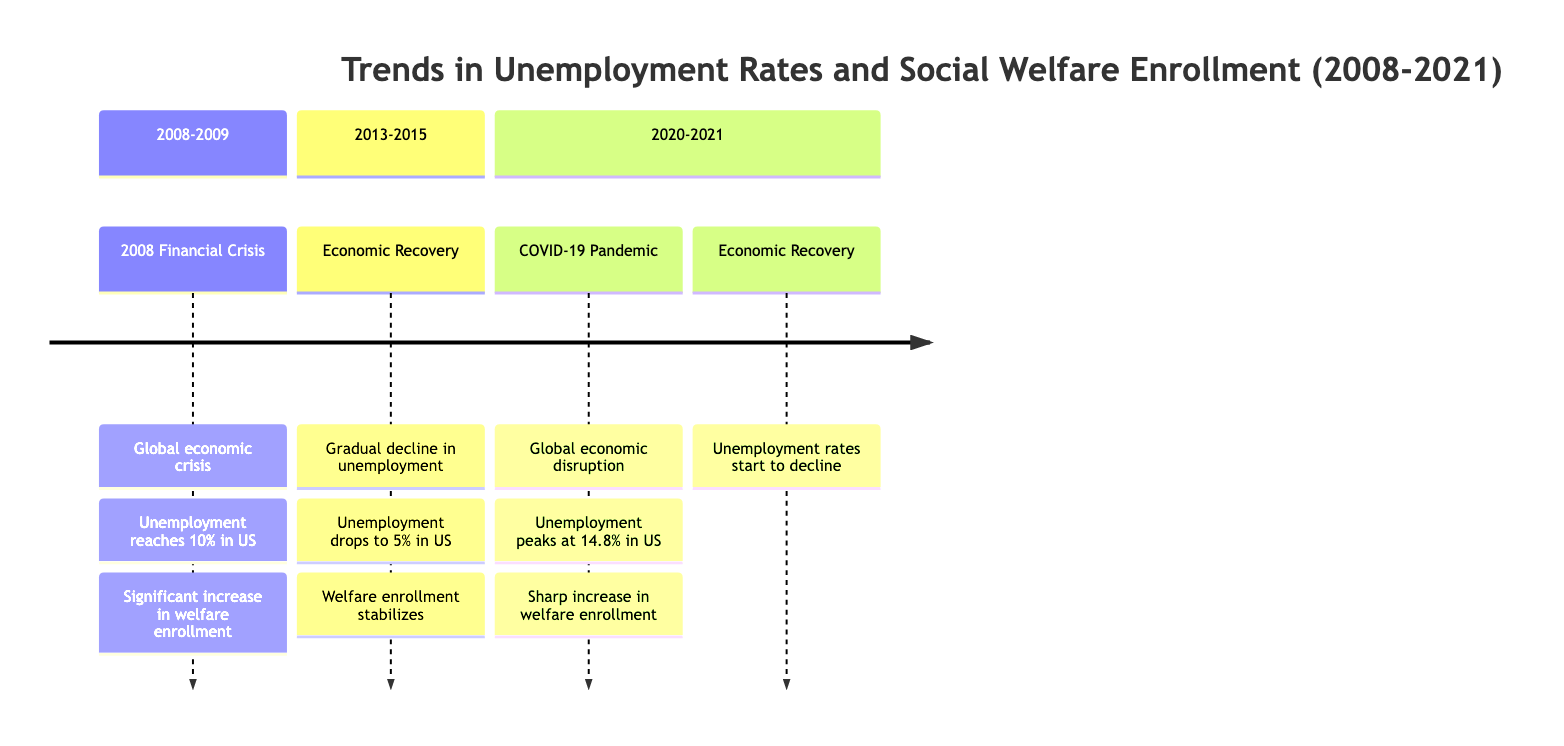What was the unemployment rate peak during the COVID-19 pandemic? The diagram notes that unemployment peaked at 14.8% during the COVID-19 pandemic, thus answering directly from the section labeled "2020-2021."
Answer: 14.8% What economic event corresponds to the spike in welfare enrollment in 2008? The diagram associates the 2008 Financial Crisis with a significant increase in welfare enrollment, linking these events within the same section.
Answer: 2008 Financial Crisis What was the unemployment rate in the U.S. in 2013? The section for "Economic Recovery" shows that by 2013, unemployment had dropped to 5%, providing the specific detail needed to answer the question.
Answer: 5% How did the welfare enrollment trend change from 2008 to 2013? The diagram illustrates a significant increase in welfare enrollment from 2008 during the financial crisis, which then stabilizes by 2013, reflecting a transition in response to economic recovery.
Answer: Increased then stabilized In which years did welfare enrollment sharply increase, and what was the cause? The diagram highlights that there was a sharp increase in welfare enrollment due to the COVID-19 pandemic in 2020-2021, combining the event and the years for a comprehensive answer.
Answer: 2020-2021, COVID-19 Pandemic What trend is shown in unemployment from 2013 to 2015? The diagram indicates a gradual decline in unemployment rates during the period labeled "Economic Recovery," which allows for effective reasoning about the trend between those years.
Answer: Gradual decline What two major economic events are highlighted in the diagram? The events specifically noted are the 2008 Financial Crisis and the COVID-19 Pandemic, both of which are emphasized in their respective sections over the historical timeline.
Answer: 2008 Financial Crisis, COVID-19 Pandemic How did unemployment rates change overall from 2020 to 2021? The timeline shows that after peaking at 14.8% in 2020 due to the pandemic, unemployment rates began to decline as indicated in the section for "Economic Recovery" for 2020-2021.
Answer: Declined What was the unemployment rate in the U.S. before the pandemic in 2020? The diagram does not provide a specific rate for unemployment immediately preceding the pandemic, but it can be inferred from the section details that it was lower than the peak of 14.8% experienced during the pandemic.
Answer: Not specified 